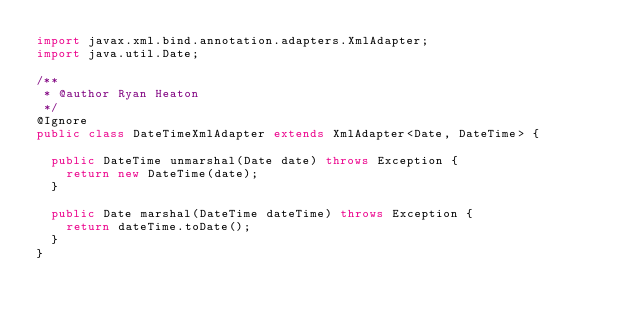<code> <loc_0><loc_0><loc_500><loc_500><_Java_>import javax.xml.bind.annotation.adapters.XmlAdapter;
import java.util.Date;

/**
 * @author Ryan Heaton
 */
@Ignore
public class DateTimeXmlAdapter extends XmlAdapter<Date, DateTime> {

  public DateTime unmarshal(Date date) throws Exception {
    return new DateTime(date);
  }

  public Date marshal(DateTime dateTime) throws Exception {
    return dateTime.toDate();
  }
}
</code> 